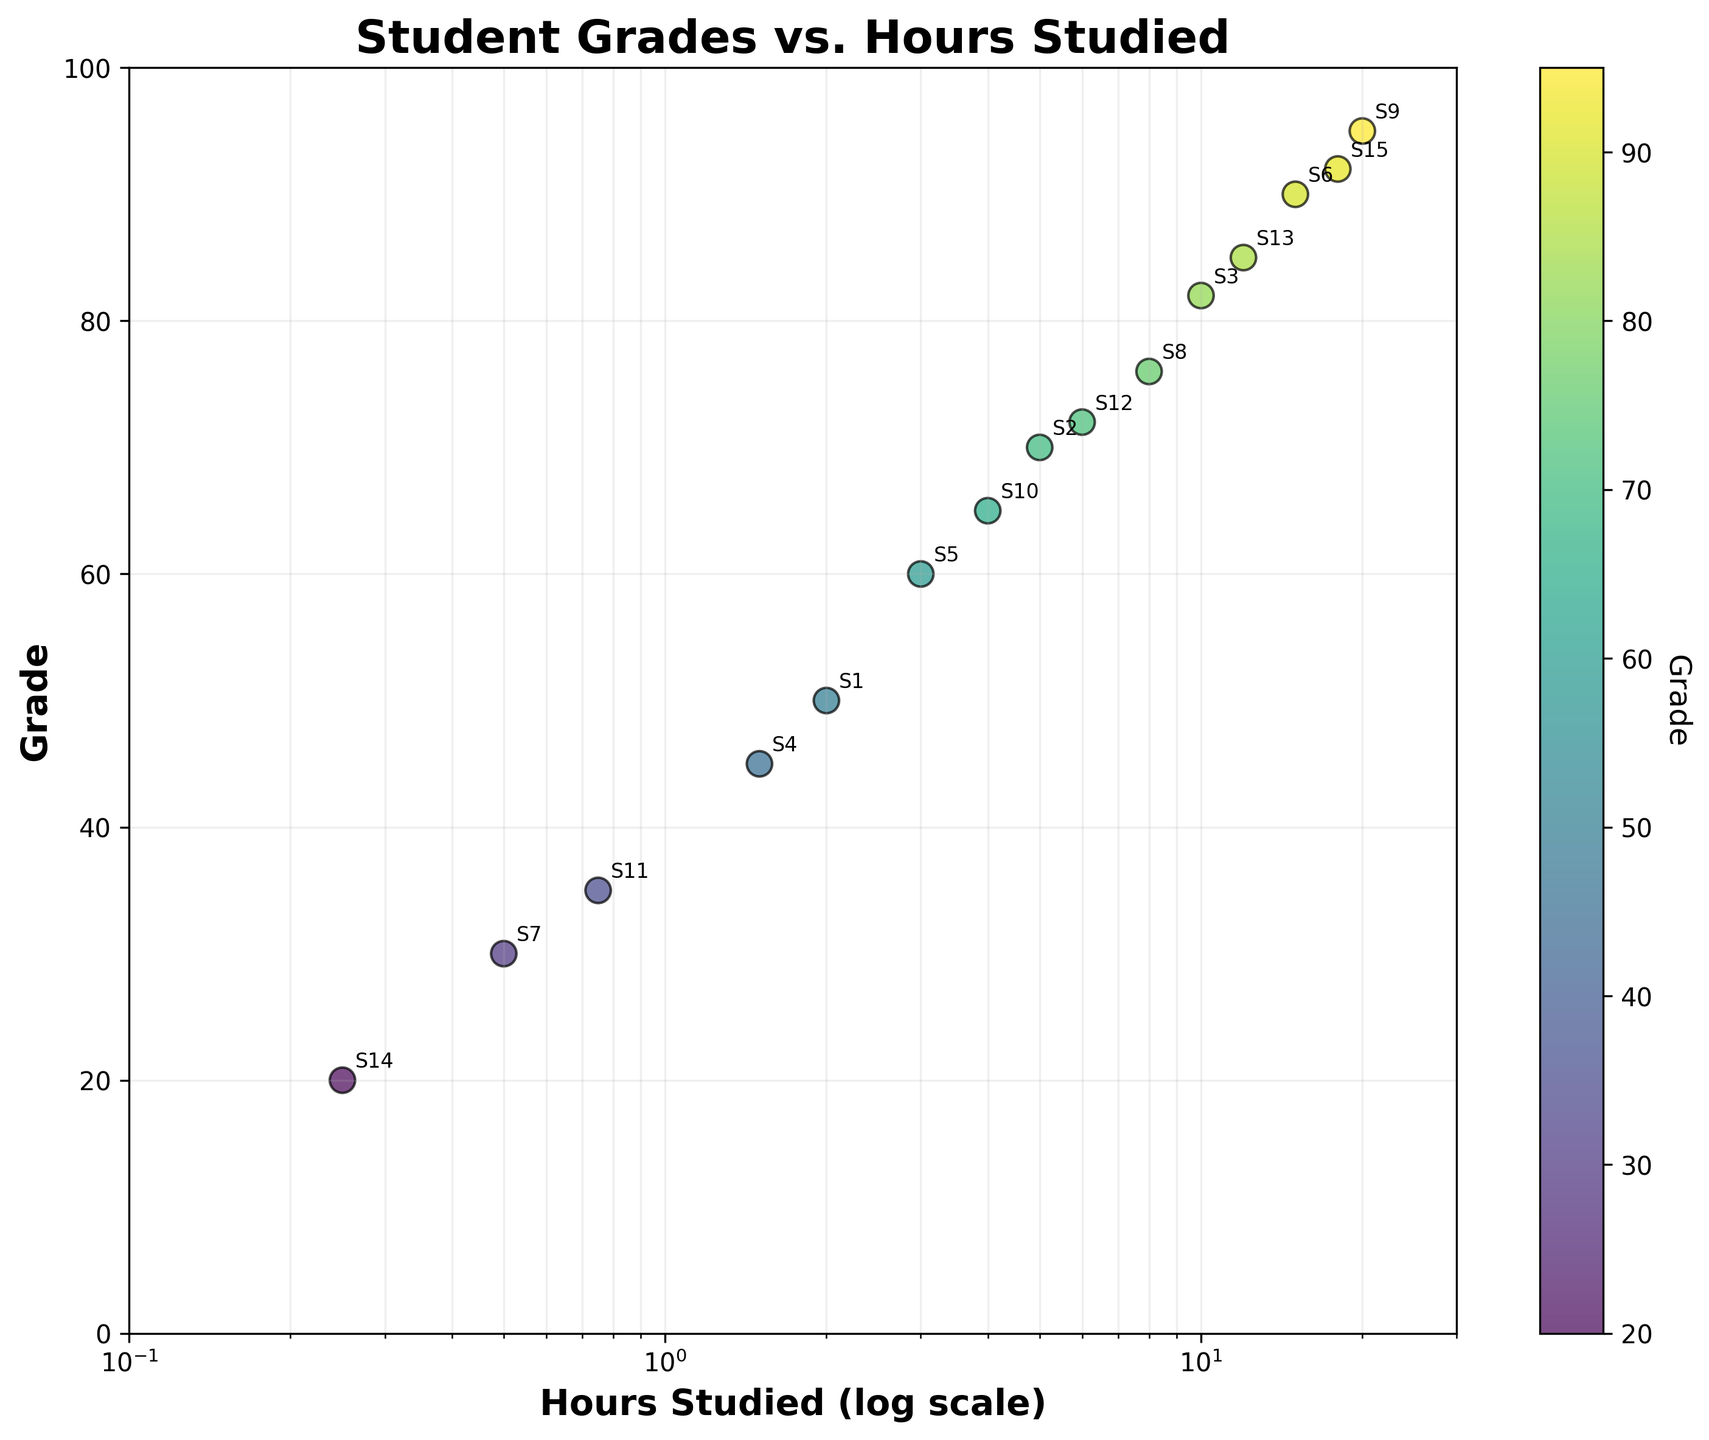what is the title of the figure? The title is displayed prominently at the top of the figure. In this case, the title is "Student Grades vs. Hours Studied."
Answer: Student Grades vs. Hours Studied How many students studied more than 10 hours? By examining the "Hours Studied" axis on a log scale, we can count the data points where hours studied exceed 10.
Answer: 4 Which student has the highest grade? Identify the highest data point on the "Grade" axis (vertical) and see the corresponding student label.
Answer: S9 What's the minimum grade observed in the figure? Identify the lowest data point on the "Grade" axis. That point represents the minimum grade recorded.
Answer: 20 What's the range of grades observed? Find the highest and lowest data points on the "Grade" axis and calculate the difference. Thus, it's 95 (highest) - 20 (lowest) = 75.
Answer: 75 How does hours studied correlate with grades? By observing the trend formed by the scatter plot points, we can see if there's a pattern. In this case, a higher hours studied generally correlates with higher grades.
Answer: Positively correlated Which students studied less than 1 hour but got a grade higher than 30? Look for data points with hours studied below 1 (log scale) and identify the corresponding points above 30 on the grade axis. These students are S7 and S11.
Answer: S7 and S11 What grade did the student who studied exactly 6 hours get? Locate the point at 6 hours on the "Hours Studied" log scale, then see its grade on the vertical axis.
Answer: 72 What is the approximate average grade of students who studied more than 5 hours? Identify the students who studied more than 5 hours, sum their grades, and divide by the number of such students. (70, 82, 90, 76, 85, 95, 92) => (70+82+90+76+85+95+92)/7 => 84.29
Answer: 84.29 